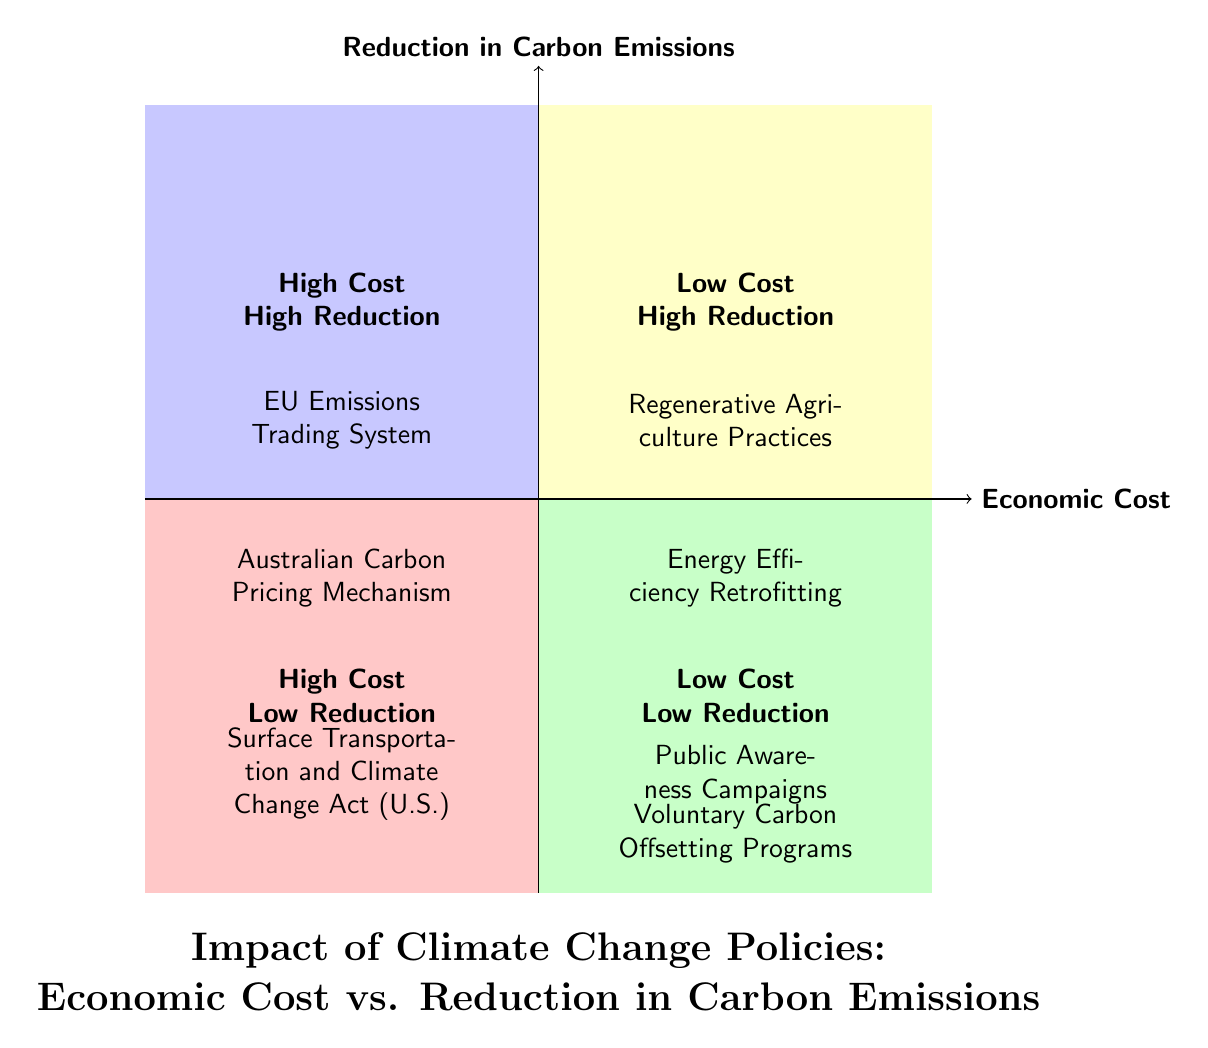What policies are in the High Cost - High Reduction quadrant? The High Cost - High Reduction quadrant contains two policies: the European Union Emissions Trading System (ETS) and the Australian Carbon Pricing Mechanism.
Answer: European Union Emissions Trading System, Australian Carbon Pricing Mechanism How many policies are in the Low Cost - Low Reduction quadrant? The Low Cost - Low Reduction quadrant contains two policies: Public Awareness Campaigns and Voluntary Carbon Offsetting Programs, summing to a total of two.
Answer: 2 Which quadrant has Regenerative Agriculture Practices? Regenerative Agriculture Practices is located in the Low Cost - High Reduction quadrant, as indicated visually by its placement.
Answer: Low Cost - High Reduction What quadrant has the highest economic cost? The High Cost - High Reduction quadrant shows policies with the highest economic costs among those shown in the chart.
Answer: High Cost - High Reduction Which policy is positioned in the Low Cost - High Reduction quadrant? The Low Cost - High Reduction quadrant includes two policies: Regenerative Agriculture Practices and Energy Efficiency Retrofitting.
Answer: Regenerative Agriculture Practices What is the relationship between Surface Transportation and Climate Change Act and Public Awareness Campaigns regarding economic cost? Surface Transportation and Climate Change Act is in the High Cost - Low Reduction quadrant while Public Awareness Campaigns are in the Low Cost - Low Reduction quadrant, indicating that the former has a higher economic cost compared to the latter.
Answer: Higher economic cost How many quadrants indicate low reduction in carbon emissions? There are two quadrants depicting low reduction in carbon emissions: High Cost - Low Reduction and Low Cost - Low Reduction, which collectively consist of four policies.
Answer: 2 Which quadrant represents policies that are low cost but also have low reduction rates? The Low Cost - Low Reduction quadrant represents those policies that are low cost and have low reduction rates.
Answer: Low Cost - Low Reduction What might be inferred about the effectiveness of policies in the High Cost - Low Reduction quadrant? Policies in the High Cost - Low Reduction quadrant, such as the Surface Transportation and Climate Change Act (U.S.) and Individual Renewable Energy Projects, are likely less effective relative to their economic costs in terms of reducing carbon emissions.
Answer: Less effective 